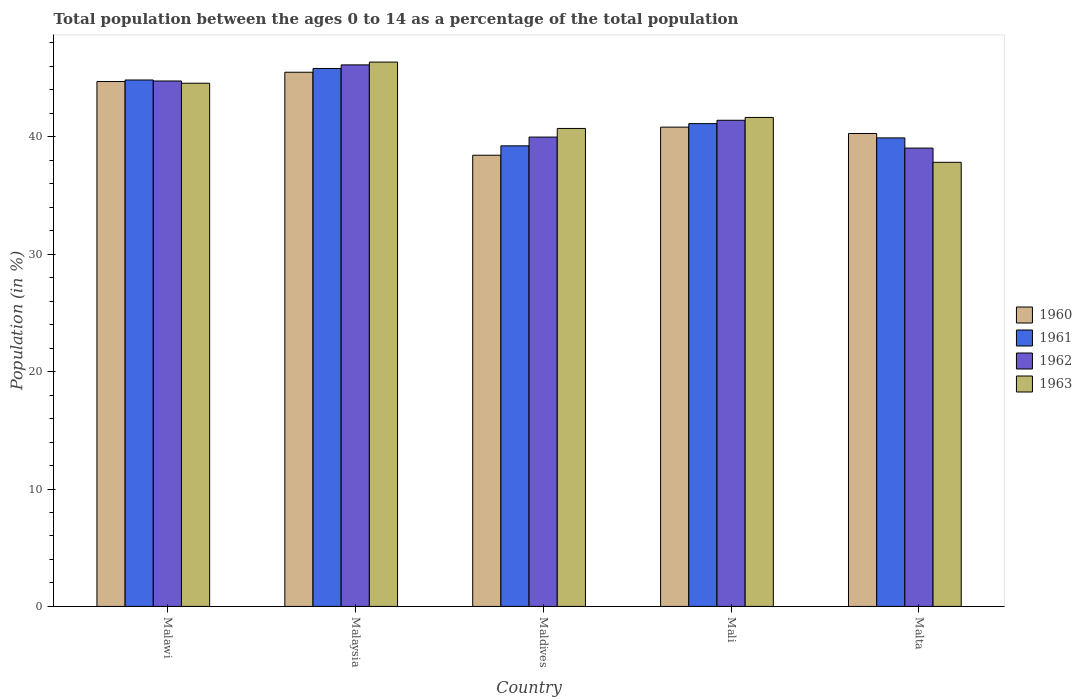How many groups of bars are there?
Provide a succinct answer. 5. Are the number of bars on each tick of the X-axis equal?
Provide a short and direct response. Yes. What is the label of the 1st group of bars from the left?
Your response must be concise. Malawi. What is the percentage of the population ages 0 to 14 in 1960 in Malta?
Offer a terse response. 40.28. Across all countries, what is the maximum percentage of the population ages 0 to 14 in 1961?
Your answer should be compact. 45.82. Across all countries, what is the minimum percentage of the population ages 0 to 14 in 1963?
Ensure brevity in your answer.  37.83. In which country was the percentage of the population ages 0 to 14 in 1960 maximum?
Offer a very short reply. Malaysia. In which country was the percentage of the population ages 0 to 14 in 1962 minimum?
Offer a terse response. Malta. What is the total percentage of the population ages 0 to 14 in 1962 in the graph?
Your answer should be compact. 211.31. What is the difference between the percentage of the population ages 0 to 14 in 1963 in Maldives and that in Mali?
Your response must be concise. -0.94. What is the difference between the percentage of the population ages 0 to 14 in 1960 in Maldives and the percentage of the population ages 0 to 14 in 1963 in Malaysia?
Provide a succinct answer. -7.93. What is the average percentage of the population ages 0 to 14 in 1963 per country?
Your answer should be very brief. 42.22. What is the difference between the percentage of the population ages 0 to 14 of/in 1962 and percentage of the population ages 0 to 14 of/in 1960 in Malaysia?
Offer a terse response. 0.63. What is the ratio of the percentage of the population ages 0 to 14 in 1961 in Malawi to that in Maldives?
Your answer should be very brief. 1.14. What is the difference between the highest and the second highest percentage of the population ages 0 to 14 in 1960?
Make the answer very short. -3.88. What is the difference between the highest and the lowest percentage of the population ages 0 to 14 in 1960?
Give a very brief answer. 7.07. In how many countries, is the percentage of the population ages 0 to 14 in 1960 greater than the average percentage of the population ages 0 to 14 in 1960 taken over all countries?
Offer a very short reply. 2. Is the sum of the percentage of the population ages 0 to 14 in 1962 in Malawi and Maldives greater than the maximum percentage of the population ages 0 to 14 in 1960 across all countries?
Offer a very short reply. Yes. How many countries are there in the graph?
Give a very brief answer. 5. What is the difference between two consecutive major ticks on the Y-axis?
Offer a terse response. 10. Does the graph contain grids?
Ensure brevity in your answer.  No. Where does the legend appear in the graph?
Provide a short and direct response. Center right. How many legend labels are there?
Your answer should be compact. 4. What is the title of the graph?
Ensure brevity in your answer.  Total population between the ages 0 to 14 as a percentage of the total population. What is the label or title of the X-axis?
Provide a short and direct response. Country. What is the label or title of the Y-axis?
Provide a succinct answer. Population (in %). What is the Population (in %) of 1960 in Malawi?
Provide a succinct answer. 44.71. What is the Population (in %) in 1961 in Malawi?
Your answer should be very brief. 44.84. What is the Population (in %) in 1962 in Malawi?
Ensure brevity in your answer.  44.75. What is the Population (in %) in 1963 in Malawi?
Your answer should be compact. 44.56. What is the Population (in %) of 1960 in Malaysia?
Give a very brief answer. 45.5. What is the Population (in %) in 1961 in Malaysia?
Make the answer very short. 45.82. What is the Population (in %) of 1962 in Malaysia?
Provide a succinct answer. 46.13. What is the Population (in %) of 1963 in Malaysia?
Provide a succinct answer. 46.36. What is the Population (in %) in 1960 in Maldives?
Provide a succinct answer. 38.43. What is the Population (in %) of 1961 in Maldives?
Give a very brief answer. 39.23. What is the Population (in %) of 1962 in Maldives?
Your answer should be compact. 39.98. What is the Population (in %) in 1963 in Maldives?
Your answer should be very brief. 40.71. What is the Population (in %) of 1960 in Mali?
Offer a terse response. 40.82. What is the Population (in %) in 1961 in Mali?
Make the answer very short. 41.12. What is the Population (in %) of 1962 in Mali?
Offer a very short reply. 41.41. What is the Population (in %) in 1963 in Mali?
Your answer should be compact. 41.65. What is the Population (in %) in 1960 in Malta?
Your answer should be very brief. 40.28. What is the Population (in %) of 1961 in Malta?
Provide a short and direct response. 39.91. What is the Population (in %) of 1962 in Malta?
Give a very brief answer. 39.04. What is the Population (in %) in 1963 in Malta?
Provide a short and direct response. 37.83. Across all countries, what is the maximum Population (in %) of 1960?
Provide a succinct answer. 45.5. Across all countries, what is the maximum Population (in %) in 1961?
Provide a short and direct response. 45.82. Across all countries, what is the maximum Population (in %) in 1962?
Your answer should be compact. 46.13. Across all countries, what is the maximum Population (in %) in 1963?
Make the answer very short. 46.36. Across all countries, what is the minimum Population (in %) in 1960?
Offer a very short reply. 38.43. Across all countries, what is the minimum Population (in %) in 1961?
Give a very brief answer. 39.23. Across all countries, what is the minimum Population (in %) of 1962?
Offer a very short reply. 39.04. Across all countries, what is the minimum Population (in %) in 1963?
Provide a succinct answer. 37.83. What is the total Population (in %) of 1960 in the graph?
Provide a short and direct response. 209.75. What is the total Population (in %) of 1961 in the graph?
Provide a short and direct response. 210.92. What is the total Population (in %) of 1962 in the graph?
Your response must be concise. 211.31. What is the total Population (in %) in 1963 in the graph?
Your answer should be compact. 211.12. What is the difference between the Population (in %) in 1960 in Malawi and that in Malaysia?
Make the answer very short. -0.79. What is the difference between the Population (in %) in 1961 in Malawi and that in Malaysia?
Offer a terse response. -0.98. What is the difference between the Population (in %) of 1962 in Malawi and that in Malaysia?
Offer a terse response. -1.37. What is the difference between the Population (in %) of 1963 in Malawi and that in Malaysia?
Provide a short and direct response. -1.8. What is the difference between the Population (in %) of 1960 in Malawi and that in Maldives?
Provide a short and direct response. 6.28. What is the difference between the Population (in %) of 1961 in Malawi and that in Maldives?
Your answer should be very brief. 5.61. What is the difference between the Population (in %) of 1962 in Malawi and that in Maldives?
Your answer should be very brief. 4.78. What is the difference between the Population (in %) in 1963 in Malawi and that in Maldives?
Ensure brevity in your answer.  3.85. What is the difference between the Population (in %) in 1960 in Malawi and that in Mali?
Provide a short and direct response. 3.88. What is the difference between the Population (in %) in 1961 in Malawi and that in Mali?
Ensure brevity in your answer.  3.72. What is the difference between the Population (in %) in 1962 in Malawi and that in Mali?
Your answer should be compact. 3.35. What is the difference between the Population (in %) of 1963 in Malawi and that in Mali?
Offer a terse response. 2.91. What is the difference between the Population (in %) of 1960 in Malawi and that in Malta?
Offer a very short reply. 4.43. What is the difference between the Population (in %) in 1961 in Malawi and that in Malta?
Provide a short and direct response. 4.93. What is the difference between the Population (in %) of 1962 in Malawi and that in Malta?
Provide a succinct answer. 5.71. What is the difference between the Population (in %) in 1963 in Malawi and that in Malta?
Give a very brief answer. 6.73. What is the difference between the Population (in %) of 1960 in Malaysia and that in Maldives?
Make the answer very short. 7.07. What is the difference between the Population (in %) in 1961 in Malaysia and that in Maldives?
Your answer should be very brief. 6.59. What is the difference between the Population (in %) of 1962 in Malaysia and that in Maldives?
Offer a very short reply. 6.15. What is the difference between the Population (in %) in 1963 in Malaysia and that in Maldives?
Offer a terse response. 5.65. What is the difference between the Population (in %) in 1960 in Malaysia and that in Mali?
Give a very brief answer. 4.68. What is the difference between the Population (in %) of 1961 in Malaysia and that in Mali?
Offer a very short reply. 4.7. What is the difference between the Population (in %) in 1962 in Malaysia and that in Mali?
Ensure brevity in your answer.  4.72. What is the difference between the Population (in %) of 1963 in Malaysia and that in Mali?
Keep it short and to the point. 4.71. What is the difference between the Population (in %) of 1960 in Malaysia and that in Malta?
Your answer should be very brief. 5.22. What is the difference between the Population (in %) in 1961 in Malaysia and that in Malta?
Provide a short and direct response. 5.91. What is the difference between the Population (in %) of 1962 in Malaysia and that in Malta?
Your answer should be compact. 7.09. What is the difference between the Population (in %) of 1963 in Malaysia and that in Malta?
Offer a very short reply. 8.54. What is the difference between the Population (in %) in 1960 in Maldives and that in Mali?
Your response must be concise. -2.39. What is the difference between the Population (in %) in 1961 in Maldives and that in Mali?
Keep it short and to the point. -1.89. What is the difference between the Population (in %) of 1962 in Maldives and that in Mali?
Provide a succinct answer. -1.43. What is the difference between the Population (in %) in 1963 in Maldives and that in Mali?
Offer a terse response. -0.94. What is the difference between the Population (in %) of 1960 in Maldives and that in Malta?
Offer a very short reply. -1.85. What is the difference between the Population (in %) of 1961 in Maldives and that in Malta?
Provide a succinct answer. -0.68. What is the difference between the Population (in %) in 1962 in Maldives and that in Malta?
Your response must be concise. 0.94. What is the difference between the Population (in %) in 1963 in Maldives and that in Malta?
Provide a succinct answer. 2.88. What is the difference between the Population (in %) of 1960 in Mali and that in Malta?
Provide a short and direct response. 0.54. What is the difference between the Population (in %) of 1961 in Mali and that in Malta?
Keep it short and to the point. 1.22. What is the difference between the Population (in %) of 1962 in Mali and that in Malta?
Give a very brief answer. 2.37. What is the difference between the Population (in %) in 1963 in Mali and that in Malta?
Ensure brevity in your answer.  3.82. What is the difference between the Population (in %) of 1960 in Malawi and the Population (in %) of 1961 in Malaysia?
Provide a succinct answer. -1.11. What is the difference between the Population (in %) of 1960 in Malawi and the Population (in %) of 1962 in Malaysia?
Offer a terse response. -1.42. What is the difference between the Population (in %) in 1960 in Malawi and the Population (in %) in 1963 in Malaysia?
Offer a very short reply. -1.66. What is the difference between the Population (in %) in 1961 in Malawi and the Population (in %) in 1962 in Malaysia?
Provide a short and direct response. -1.29. What is the difference between the Population (in %) in 1961 in Malawi and the Population (in %) in 1963 in Malaysia?
Ensure brevity in your answer.  -1.52. What is the difference between the Population (in %) in 1962 in Malawi and the Population (in %) in 1963 in Malaysia?
Ensure brevity in your answer.  -1.61. What is the difference between the Population (in %) of 1960 in Malawi and the Population (in %) of 1961 in Maldives?
Give a very brief answer. 5.48. What is the difference between the Population (in %) in 1960 in Malawi and the Population (in %) in 1962 in Maldives?
Keep it short and to the point. 4.73. What is the difference between the Population (in %) of 1960 in Malawi and the Population (in %) of 1963 in Maldives?
Your response must be concise. 4. What is the difference between the Population (in %) of 1961 in Malawi and the Population (in %) of 1962 in Maldives?
Your answer should be very brief. 4.86. What is the difference between the Population (in %) of 1961 in Malawi and the Population (in %) of 1963 in Maldives?
Your answer should be very brief. 4.13. What is the difference between the Population (in %) of 1962 in Malawi and the Population (in %) of 1963 in Maldives?
Offer a very short reply. 4.04. What is the difference between the Population (in %) of 1960 in Malawi and the Population (in %) of 1961 in Mali?
Provide a short and direct response. 3.59. What is the difference between the Population (in %) in 1960 in Malawi and the Population (in %) in 1962 in Mali?
Ensure brevity in your answer.  3.3. What is the difference between the Population (in %) in 1960 in Malawi and the Population (in %) in 1963 in Mali?
Provide a short and direct response. 3.06. What is the difference between the Population (in %) of 1961 in Malawi and the Population (in %) of 1962 in Mali?
Provide a succinct answer. 3.43. What is the difference between the Population (in %) in 1961 in Malawi and the Population (in %) in 1963 in Mali?
Offer a very short reply. 3.19. What is the difference between the Population (in %) in 1962 in Malawi and the Population (in %) in 1963 in Mali?
Make the answer very short. 3.11. What is the difference between the Population (in %) of 1960 in Malawi and the Population (in %) of 1961 in Malta?
Give a very brief answer. 4.8. What is the difference between the Population (in %) in 1960 in Malawi and the Population (in %) in 1962 in Malta?
Provide a short and direct response. 5.67. What is the difference between the Population (in %) of 1960 in Malawi and the Population (in %) of 1963 in Malta?
Offer a terse response. 6.88. What is the difference between the Population (in %) of 1961 in Malawi and the Population (in %) of 1962 in Malta?
Offer a very short reply. 5.8. What is the difference between the Population (in %) in 1961 in Malawi and the Population (in %) in 1963 in Malta?
Your answer should be compact. 7.01. What is the difference between the Population (in %) of 1962 in Malawi and the Population (in %) of 1963 in Malta?
Your response must be concise. 6.93. What is the difference between the Population (in %) in 1960 in Malaysia and the Population (in %) in 1961 in Maldives?
Provide a succinct answer. 6.27. What is the difference between the Population (in %) of 1960 in Malaysia and the Population (in %) of 1962 in Maldives?
Give a very brief answer. 5.52. What is the difference between the Population (in %) in 1960 in Malaysia and the Population (in %) in 1963 in Maldives?
Give a very brief answer. 4.79. What is the difference between the Population (in %) of 1961 in Malaysia and the Population (in %) of 1962 in Maldives?
Your answer should be very brief. 5.84. What is the difference between the Population (in %) of 1961 in Malaysia and the Population (in %) of 1963 in Maldives?
Offer a very short reply. 5.11. What is the difference between the Population (in %) of 1962 in Malaysia and the Population (in %) of 1963 in Maldives?
Offer a very short reply. 5.41. What is the difference between the Population (in %) of 1960 in Malaysia and the Population (in %) of 1961 in Mali?
Provide a short and direct response. 4.38. What is the difference between the Population (in %) of 1960 in Malaysia and the Population (in %) of 1962 in Mali?
Offer a very short reply. 4.09. What is the difference between the Population (in %) of 1960 in Malaysia and the Population (in %) of 1963 in Mali?
Provide a short and direct response. 3.85. What is the difference between the Population (in %) in 1961 in Malaysia and the Population (in %) in 1962 in Mali?
Make the answer very short. 4.41. What is the difference between the Population (in %) of 1961 in Malaysia and the Population (in %) of 1963 in Mali?
Give a very brief answer. 4.17. What is the difference between the Population (in %) of 1962 in Malaysia and the Population (in %) of 1963 in Mali?
Provide a succinct answer. 4.48. What is the difference between the Population (in %) of 1960 in Malaysia and the Population (in %) of 1961 in Malta?
Ensure brevity in your answer.  5.59. What is the difference between the Population (in %) in 1960 in Malaysia and the Population (in %) in 1962 in Malta?
Ensure brevity in your answer.  6.46. What is the difference between the Population (in %) in 1960 in Malaysia and the Population (in %) in 1963 in Malta?
Ensure brevity in your answer.  7.67. What is the difference between the Population (in %) in 1961 in Malaysia and the Population (in %) in 1962 in Malta?
Make the answer very short. 6.78. What is the difference between the Population (in %) in 1961 in Malaysia and the Population (in %) in 1963 in Malta?
Offer a very short reply. 7.99. What is the difference between the Population (in %) in 1962 in Malaysia and the Population (in %) in 1963 in Malta?
Provide a short and direct response. 8.3. What is the difference between the Population (in %) in 1960 in Maldives and the Population (in %) in 1961 in Mali?
Offer a very short reply. -2.69. What is the difference between the Population (in %) of 1960 in Maldives and the Population (in %) of 1962 in Mali?
Provide a succinct answer. -2.98. What is the difference between the Population (in %) in 1960 in Maldives and the Population (in %) in 1963 in Mali?
Your response must be concise. -3.22. What is the difference between the Population (in %) of 1961 in Maldives and the Population (in %) of 1962 in Mali?
Make the answer very short. -2.18. What is the difference between the Population (in %) in 1961 in Maldives and the Population (in %) in 1963 in Mali?
Keep it short and to the point. -2.42. What is the difference between the Population (in %) of 1962 in Maldives and the Population (in %) of 1963 in Mali?
Offer a very short reply. -1.67. What is the difference between the Population (in %) of 1960 in Maldives and the Population (in %) of 1961 in Malta?
Ensure brevity in your answer.  -1.48. What is the difference between the Population (in %) of 1960 in Maldives and the Population (in %) of 1962 in Malta?
Provide a succinct answer. -0.61. What is the difference between the Population (in %) in 1960 in Maldives and the Population (in %) in 1963 in Malta?
Your answer should be very brief. 0.6. What is the difference between the Population (in %) in 1961 in Maldives and the Population (in %) in 1962 in Malta?
Give a very brief answer. 0.19. What is the difference between the Population (in %) of 1961 in Maldives and the Population (in %) of 1963 in Malta?
Keep it short and to the point. 1.4. What is the difference between the Population (in %) in 1962 in Maldives and the Population (in %) in 1963 in Malta?
Offer a terse response. 2.15. What is the difference between the Population (in %) in 1960 in Mali and the Population (in %) in 1961 in Malta?
Offer a very short reply. 0.92. What is the difference between the Population (in %) of 1960 in Mali and the Population (in %) of 1962 in Malta?
Give a very brief answer. 1.78. What is the difference between the Population (in %) in 1960 in Mali and the Population (in %) in 1963 in Malta?
Give a very brief answer. 3. What is the difference between the Population (in %) in 1961 in Mali and the Population (in %) in 1962 in Malta?
Provide a short and direct response. 2.08. What is the difference between the Population (in %) of 1961 in Mali and the Population (in %) of 1963 in Malta?
Your answer should be compact. 3.29. What is the difference between the Population (in %) in 1962 in Mali and the Population (in %) in 1963 in Malta?
Make the answer very short. 3.58. What is the average Population (in %) in 1960 per country?
Offer a very short reply. 41.95. What is the average Population (in %) of 1961 per country?
Your answer should be very brief. 42.18. What is the average Population (in %) of 1962 per country?
Give a very brief answer. 42.26. What is the average Population (in %) of 1963 per country?
Provide a succinct answer. 42.22. What is the difference between the Population (in %) in 1960 and Population (in %) in 1961 in Malawi?
Offer a very short reply. -0.13. What is the difference between the Population (in %) in 1960 and Population (in %) in 1962 in Malawi?
Make the answer very short. -0.05. What is the difference between the Population (in %) of 1960 and Population (in %) of 1963 in Malawi?
Offer a very short reply. 0.14. What is the difference between the Population (in %) of 1961 and Population (in %) of 1962 in Malawi?
Make the answer very short. 0.08. What is the difference between the Population (in %) in 1961 and Population (in %) in 1963 in Malawi?
Make the answer very short. 0.28. What is the difference between the Population (in %) in 1962 and Population (in %) in 1963 in Malawi?
Offer a terse response. 0.19. What is the difference between the Population (in %) in 1960 and Population (in %) in 1961 in Malaysia?
Provide a short and direct response. -0.32. What is the difference between the Population (in %) of 1960 and Population (in %) of 1962 in Malaysia?
Ensure brevity in your answer.  -0.63. What is the difference between the Population (in %) of 1960 and Population (in %) of 1963 in Malaysia?
Make the answer very short. -0.86. What is the difference between the Population (in %) in 1961 and Population (in %) in 1962 in Malaysia?
Offer a terse response. -0.31. What is the difference between the Population (in %) of 1961 and Population (in %) of 1963 in Malaysia?
Offer a very short reply. -0.54. What is the difference between the Population (in %) of 1962 and Population (in %) of 1963 in Malaysia?
Your answer should be compact. -0.24. What is the difference between the Population (in %) in 1960 and Population (in %) in 1961 in Maldives?
Your answer should be very brief. -0.8. What is the difference between the Population (in %) in 1960 and Population (in %) in 1962 in Maldives?
Provide a succinct answer. -1.55. What is the difference between the Population (in %) of 1960 and Population (in %) of 1963 in Maldives?
Keep it short and to the point. -2.28. What is the difference between the Population (in %) in 1961 and Population (in %) in 1962 in Maldives?
Your answer should be very brief. -0.75. What is the difference between the Population (in %) in 1961 and Population (in %) in 1963 in Maldives?
Your response must be concise. -1.48. What is the difference between the Population (in %) of 1962 and Population (in %) of 1963 in Maldives?
Keep it short and to the point. -0.73. What is the difference between the Population (in %) in 1960 and Population (in %) in 1961 in Mali?
Give a very brief answer. -0.3. What is the difference between the Population (in %) of 1960 and Population (in %) of 1962 in Mali?
Ensure brevity in your answer.  -0.58. What is the difference between the Population (in %) of 1960 and Population (in %) of 1963 in Mali?
Offer a terse response. -0.82. What is the difference between the Population (in %) of 1961 and Population (in %) of 1962 in Mali?
Give a very brief answer. -0.29. What is the difference between the Population (in %) in 1961 and Population (in %) in 1963 in Mali?
Provide a succinct answer. -0.53. What is the difference between the Population (in %) of 1962 and Population (in %) of 1963 in Mali?
Offer a terse response. -0.24. What is the difference between the Population (in %) of 1960 and Population (in %) of 1961 in Malta?
Provide a short and direct response. 0.37. What is the difference between the Population (in %) of 1960 and Population (in %) of 1962 in Malta?
Your answer should be compact. 1.24. What is the difference between the Population (in %) in 1960 and Population (in %) in 1963 in Malta?
Offer a very short reply. 2.45. What is the difference between the Population (in %) in 1961 and Population (in %) in 1962 in Malta?
Your response must be concise. 0.87. What is the difference between the Population (in %) in 1961 and Population (in %) in 1963 in Malta?
Ensure brevity in your answer.  2.08. What is the difference between the Population (in %) in 1962 and Population (in %) in 1963 in Malta?
Your response must be concise. 1.21. What is the ratio of the Population (in %) in 1960 in Malawi to that in Malaysia?
Give a very brief answer. 0.98. What is the ratio of the Population (in %) in 1961 in Malawi to that in Malaysia?
Offer a terse response. 0.98. What is the ratio of the Population (in %) in 1962 in Malawi to that in Malaysia?
Offer a very short reply. 0.97. What is the ratio of the Population (in %) of 1963 in Malawi to that in Malaysia?
Offer a very short reply. 0.96. What is the ratio of the Population (in %) in 1960 in Malawi to that in Maldives?
Give a very brief answer. 1.16. What is the ratio of the Population (in %) in 1961 in Malawi to that in Maldives?
Give a very brief answer. 1.14. What is the ratio of the Population (in %) in 1962 in Malawi to that in Maldives?
Your answer should be very brief. 1.12. What is the ratio of the Population (in %) of 1963 in Malawi to that in Maldives?
Keep it short and to the point. 1.09. What is the ratio of the Population (in %) in 1960 in Malawi to that in Mali?
Make the answer very short. 1.1. What is the ratio of the Population (in %) of 1961 in Malawi to that in Mali?
Provide a succinct answer. 1.09. What is the ratio of the Population (in %) of 1962 in Malawi to that in Mali?
Your response must be concise. 1.08. What is the ratio of the Population (in %) of 1963 in Malawi to that in Mali?
Provide a succinct answer. 1.07. What is the ratio of the Population (in %) in 1960 in Malawi to that in Malta?
Offer a very short reply. 1.11. What is the ratio of the Population (in %) of 1961 in Malawi to that in Malta?
Provide a short and direct response. 1.12. What is the ratio of the Population (in %) in 1962 in Malawi to that in Malta?
Offer a very short reply. 1.15. What is the ratio of the Population (in %) in 1963 in Malawi to that in Malta?
Make the answer very short. 1.18. What is the ratio of the Population (in %) in 1960 in Malaysia to that in Maldives?
Offer a terse response. 1.18. What is the ratio of the Population (in %) in 1961 in Malaysia to that in Maldives?
Offer a very short reply. 1.17. What is the ratio of the Population (in %) of 1962 in Malaysia to that in Maldives?
Your answer should be very brief. 1.15. What is the ratio of the Population (in %) of 1963 in Malaysia to that in Maldives?
Your answer should be very brief. 1.14. What is the ratio of the Population (in %) in 1960 in Malaysia to that in Mali?
Give a very brief answer. 1.11. What is the ratio of the Population (in %) of 1961 in Malaysia to that in Mali?
Ensure brevity in your answer.  1.11. What is the ratio of the Population (in %) of 1962 in Malaysia to that in Mali?
Offer a very short reply. 1.11. What is the ratio of the Population (in %) in 1963 in Malaysia to that in Mali?
Offer a terse response. 1.11. What is the ratio of the Population (in %) in 1960 in Malaysia to that in Malta?
Your response must be concise. 1.13. What is the ratio of the Population (in %) of 1961 in Malaysia to that in Malta?
Your answer should be very brief. 1.15. What is the ratio of the Population (in %) of 1962 in Malaysia to that in Malta?
Offer a terse response. 1.18. What is the ratio of the Population (in %) of 1963 in Malaysia to that in Malta?
Your response must be concise. 1.23. What is the ratio of the Population (in %) in 1960 in Maldives to that in Mali?
Your answer should be compact. 0.94. What is the ratio of the Population (in %) in 1961 in Maldives to that in Mali?
Ensure brevity in your answer.  0.95. What is the ratio of the Population (in %) in 1962 in Maldives to that in Mali?
Keep it short and to the point. 0.97. What is the ratio of the Population (in %) of 1963 in Maldives to that in Mali?
Keep it short and to the point. 0.98. What is the ratio of the Population (in %) in 1960 in Maldives to that in Malta?
Make the answer very short. 0.95. What is the ratio of the Population (in %) in 1961 in Maldives to that in Malta?
Provide a short and direct response. 0.98. What is the ratio of the Population (in %) in 1962 in Maldives to that in Malta?
Your answer should be compact. 1.02. What is the ratio of the Population (in %) in 1963 in Maldives to that in Malta?
Your answer should be compact. 1.08. What is the ratio of the Population (in %) in 1960 in Mali to that in Malta?
Keep it short and to the point. 1.01. What is the ratio of the Population (in %) of 1961 in Mali to that in Malta?
Make the answer very short. 1.03. What is the ratio of the Population (in %) in 1962 in Mali to that in Malta?
Make the answer very short. 1.06. What is the ratio of the Population (in %) in 1963 in Mali to that in Malta?
Your response must be concise. 1.1. What is the difference between the highest and the second highest Population (in %) of 1960?
Keep it short and to the point. 0.79. What is the difference between the highest and the second highest Population (in %) of 1961?
Offer a very short reply. 0.98. What is the difference between the highest and the second highest Population (in %) of 1962?
Make the answer very short. 1.37. What is the difference between the highest and the second highest Population (in %) of 1963?
Keep it short and to the point. 1.8. What is the difference between the highest and the lowest Population (in %) of 1960?
Your response must be concise. 7.07. What is the difference between the highest and the lowest Population (in %) in 1961?
Make the answer very short. 6.59. What is the difference between the highest and the lowest Population (in %) of 1962?
Keep it short and to the point. 7.09. What is the difference between the highest and the lowest Population (in %) in 1963?
Provide a short and direct response. 8.54. 